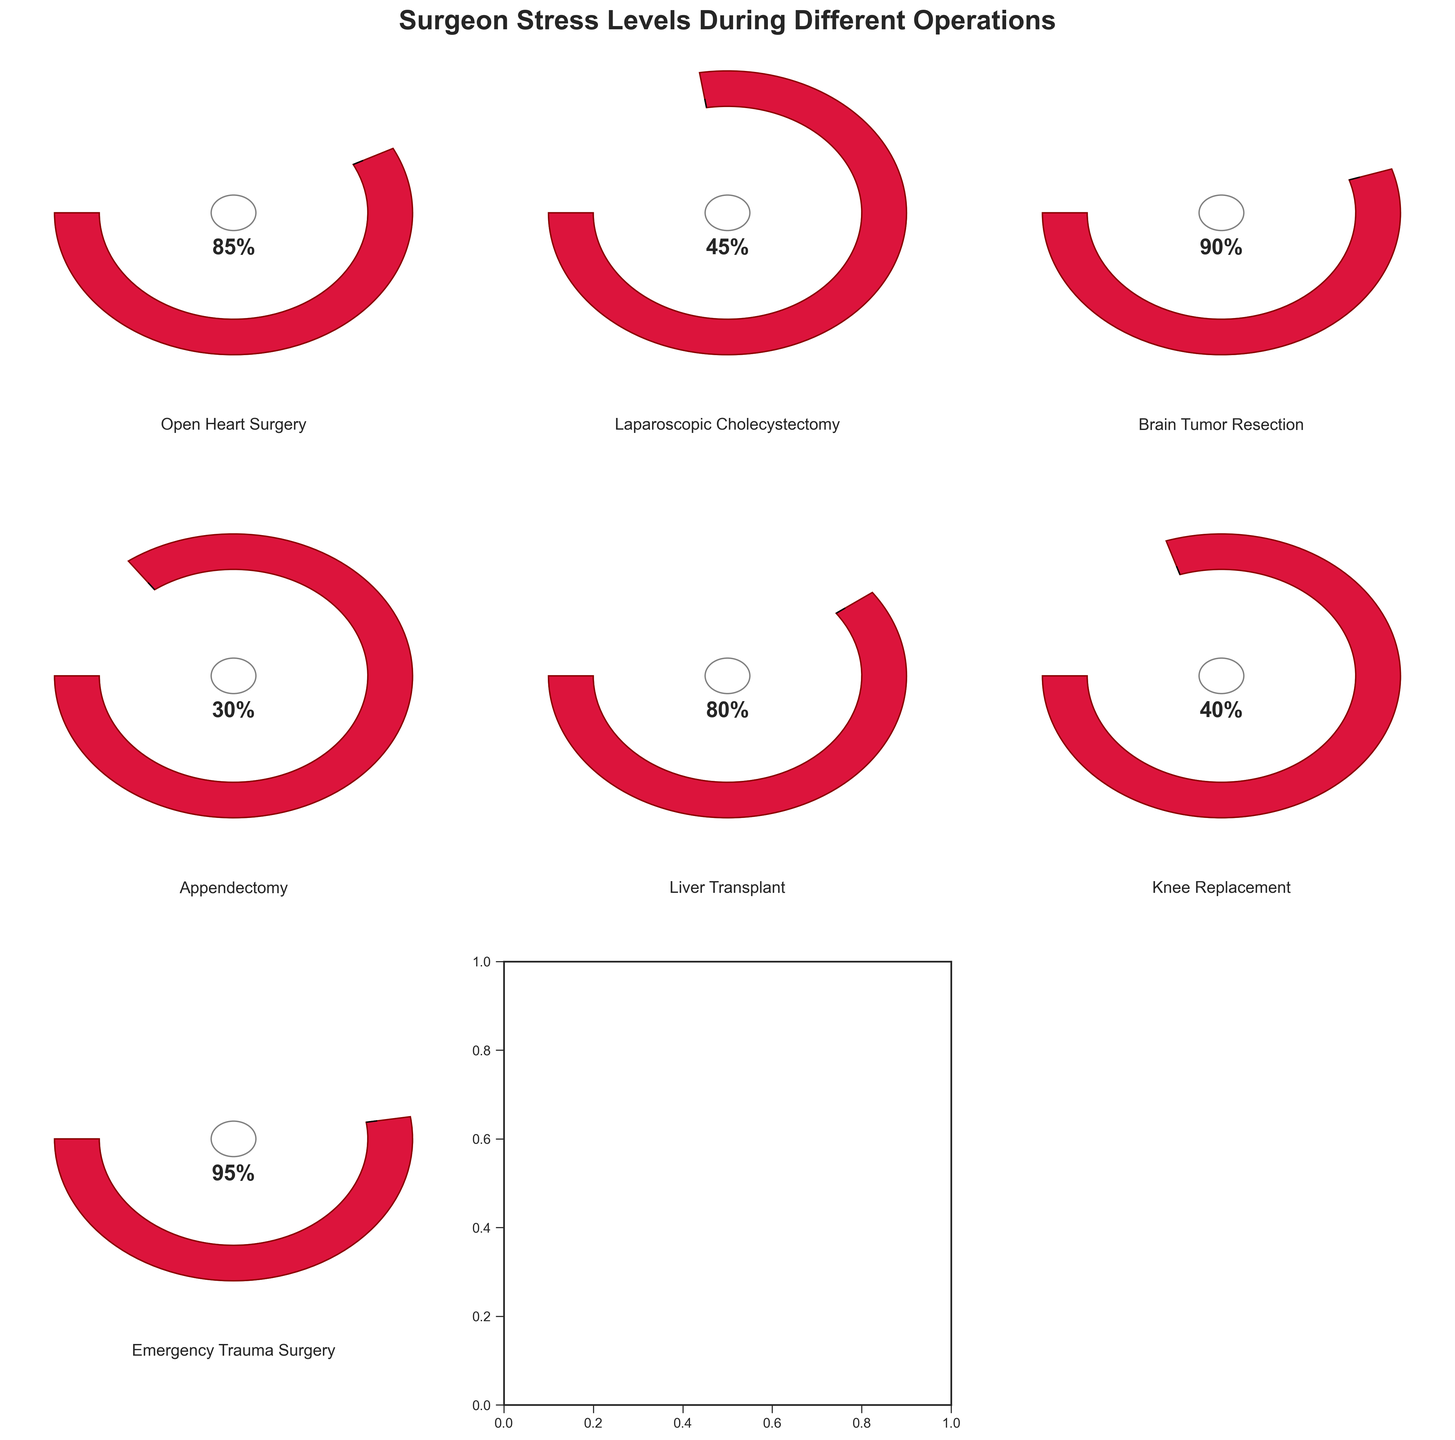What is the title of the figure? The title is often positioned at the top of the figure. In this case, it states "Surgeon Stress Levels During Different Operations", which describes what the figure represents.
Answer: Surgeon Stress Levels During Different Operations Which operation shows the highest stress level for the surgeon? Identify the gauge chart with the highest percentage shown. The figure for Emergency Trauma Surgery has the highest stress level at 95%.
Answer: Emergency Trauma Surgery How many different types of operations are depicted in the figure? Count the number of separate gauge charts, one for each operation. There are seven gauge charts.
Answer: Seven What is the stress level for a surgeon during a Liver Transplant? Locate the gauge chart labeled "Liver Transplant" and note the indicated stress percentage. It shows 80%.
Answer: 80% Which operation has the lowest stress level, and what is it? Identify the gauge chart with the lowest percentage. The operation with the lowest stress level is Appendectomy at 30%.
Answer: Appendectomy, 30% What is the average stress level across all the depicted surgeries? Add all stress levels: (85 + 45 + 90 + 30 + 80 + 40 + 95) = 465, then divide by the number of operations, which is 7. So, 465 / 7 ≈ 66.4.
Answer: 66.4 Compare the stress levels of Open Heart Surgery and Brain Tumor Resection. Which one is higher and by how much? Open Heart Surgery has a stress level of 85, and Brain Tumor Resection has 90. The difference is 90 - 85 = 5, so Brain Tumor Resection is higher by 5%.
Answer: Brain Tumor Resection, 5% Which operations have stress levels above 80? Identify operations where the gauge percentage is greater than 80. They are Open Heart Surgery (85), Brain Tumor Resection (90), Liver Transplant (80), and Emergency Trauma Surgery (95).
Answer: Open Heart Surgery, Brain Tumor Resection, Emergency Trauma Surgery What is the median stress level of the operations? List the stress levels in ascending order: 30, 40, 45, 80, 85, 90, 95. The median value is the middle one in the ordered list: 80.
Answer: 80 How do the stress levels of Laparoscopic Cholecystectomy and Knee Replacement compare? Laparoscopic Cholecystectomy has a stress level of 45, and Knee Replacement has 40. Laparoscopic Cholecystectomy is 5% higher than Knee Replacement.
Answer: Laparoscopic Cholecystectomy is 5% higher than Knee Replacement 